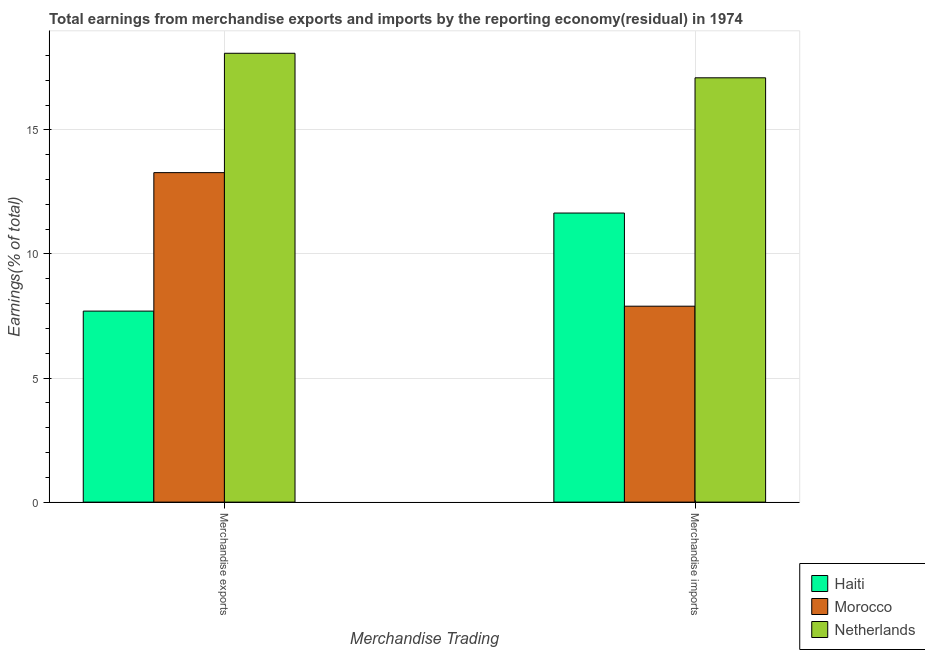How many different coloured bars are there?
Ensure brevity in your answer.  3. How many groups of bars are there?
Provide a short and direct response. 2. Are the number of bars per tick equal to the number of legend labels?
Keep it short and to the point. Yes. Are the number of bars on each tick of the X-axis equal?
Give a very brief answer. Yes. How many bars are there on the 2nd tick from the left?
Your answer should be compact. 3. What is the earnings from merchandise exports in Haiti?
Provide a succinct answer. 7.7. Across all countries, what is the maximum earnings from merchandise imports?
Your answer should be very brief. 17.1. Across all countries, what is the minimum earnings from merchandise exports?
Your answer should be very brief. 7.7. In which country was the earnings from merchandise imports maximum?
Your answer should be compact. Netherlands. In which country was the earnings from merchandise imports minimum?
Provide a succinct answer. Morocco. What is the total earnings from merchandise imports in the graph?
Ensure brevity in your answer.  36.65. What is the difference between the earnings from merchandise imports in Haiti and that in Morocco?
Offer a very short reply. 3.75. What is the difference between the earnings from merchandise imports in Netherlands and the earnings from merchandise exports in Morocco?
Make the answer very short. 3.82. What is the average earnings from merchandise imports per country?
Give a very brief answer. 12.22. What is the difference between the earnings from merchandise exports and earnings from merchandise imports in Haiti?
Provide a succinct answer. -3.95. What is the ratio of the earnings from merchandise exports in Netherlands to that in Haiti?
Your response must be concise. 2.35. Is the earnings from merchandise imports in Morocco less than that in Haiti?
Keep it short and to the point. Yes. What does the 1st bar from the left in Merchandise exports represents?
Ensure brevity in your answer.  Haiti. What does the 2nd bar from the right in Merchandise exports represents?
Make the answer very short. Morocco. Are all the bars in the graph horizontal?
Your response must be concise. No. How many countries are there in the graph?
Give a very brief answer. 3. What is the difference between two consecutive major ticks on the Y-axis?
Provide a succinct answer. 5. Are the values on the major ticks of Y-axis written in scientific E-notation?
Give a very brief answer. No. How many legend labels are there?
Offer a very short reply. 3. What is the title of the graph?
Offer a terse response. Total earnings from merchandise exports and imports by the reporting economy(residual) in 1974. Does "Dominican Republic" appear as one of the legend labels in the graph?
Give a very brief answer. No. What is the label or title of the X-axis?
Your answer should be compact. Merchandise Trading. What is the label or title of the Y-axis?
Offer a terse response. Earnings(% of total). What is the Earnings(% of total) of Haiti in Merchandise exports?
Offer a very short reply. 7.7. What is the Earnings(% of total) in Morocco in Merchandise exports?
Offer a very short reply. 13.28. What is the Earnings(% of total) of Netherlands in Merchandise exports?
Your response must be concise. 18.09. What is the Earnings(% of total) in Haiti in Merchandise imports?
Your answer should be compact. 11.65. What is the Earnings(% of total) in Morocco in Merchandise imports?
Offer a very short reply. 7.9. What is the Earnings(% of total) in Netherlands in Merchandise imports?
Give a very brief answer. 17.1. Across all Merchandise Trading, what is the maximum Earnings(% of total) in Haiti?
Your response must be concise. 11.65. Across all Merchandise Trading, what is the maximum Earnings(% of total) in Morocco?
Give a very brief answer. 13.28. Across all Merchandise Trading, what is the maximum Earnings(% of total) in Netherlands?
Make the answer very short. 18.09. Across all Merchandise Trading, what is the minimum Earnings(% of total) in Haiti?
Offer a terse response. 7.7. Across all Merchandise Trading, what is the minimum Earnings(% of total) of Morocco?
Offer a terse response. 7.9. Across all Merchandise Trading, what is the minimum Earnings(% of total) of Netherlands?
Give a very brief answer. 17.1. What is the total Earnings(% of total) in Haiti in the graph?
Give a very brief answer. 19.35. What is the total Earnings(% of total) of Morocco in the graph?
Provide a short and direct response. 21.17. What is the total Earnings(% of total) of Netherlands in the graph?
Ensure brevity in your answer.  35.19. What is the difference between the Earnings(% of total) in Haiti in Merchandise exports and that in Merchandise imports?
Give a very brief answer. -3.95. What is the difference between the Earnings(% of total) of Morocco in Merchandise exports and that in Merchandise imports?
Your answer should be very brief. 5.38. What is the difference between the Earnings(% of total) of Haiti in Merchandise exports and the Earnings(% of total) of Morocco in Merchandise imports?
Offer a terse response. -0.2. What is the difference between the Earnings(% of total) of Haiti in Merchandise exports and the Earnings(% of total) of Netherlands in Merchandise imports?
Your answer should be compact. -9.4. What is the difference between the Earnings(% of total) in Morocco in Merchandise exports and the Earnings(% of total) in Netherlands in Merchandise imports?
Keep it short and to the point. -3.82. What is the average Earnings(% of total) of Haiti per Merchandise Trading?
Give a very brief answer. 9.67. What is the average Earnings(% of total) in Morocco per Merchandise Trading?
Your response must be concise. 10.59. What is the average Earnings(% of total) in Netherlands per Merchandise Trading?
Provide a short and direct response. 17.59. What is the difference between the Earnings(% of total) of Haiti and Earnings(% of total) of Morocco in Merchandise exports?
Keep it short and to the point. -5.58. What is the difference between the Earnings(% of total) in Haiti and Earnings(% of total) in Netherlands in Merchandise exports?
Your response must be concise. -10.39. What is the difference between the Earnings(% of total) of Morocco and Earnings(% of total) of Netherlands in Merchandise exports?
Offer a very short reply. -4.81. What is the difference between the Earnings(% of total) in Haiti and Earnings(% of total) in Morocco in Merchandise imports?
Give a very brief answer. 3.75. What is the difference between the Earnings(% of total) in Haiti and Earnings(% of total) in Netherlands in Merchandise imports?
Offer a terse response. -5.45. What is the difference between the Earnings(% of total) in Morocco and Earnings(% of total) in Netherlands in Merchandise imports?
Keep it short and to the point. -9.2. What is the ratio of the Earnings(% of total) of Haiti in Merchandise exports to that in Merchandise imports?
Ensure brevity in your answer.  0.66. What is the ratio of the Earnings(% of total) of Morocco in Merchandise exports to that in Merchandise imports?
Your answer should be very brief. 1.68. What is the ratio of the Earnings(% of total) of Netherlands in Merchandise exports to that in Merchandise imports?
Offer a very short reply. 1.06. What is the difference between the highest and the second highest Earnings(% of total) in Haiti?
Give a very brief answer. 3.95. What is the difference between the highest and the second highest Earnings(% of total) of Morocco?
Provide a succinct answer. 5.38. What is the difference between the highest and the second highest Earnings(% of total) of Netherlands?
Ensure brevity in your answer.  0.99. What is the difference between the highest and the lowest Earnings(% of total) in Haiti?
Your answer should be compact. 3.95. What is the difference between the highest and the lowest Earnings(% of total) of Morocco?
Ensure brevity in your answer.  5.38. What is the difference between the highest and the lowest Earnings(% of total) in Netherlands?
Ensure brevity in your answer.  0.99. 